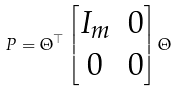Convert formula to latex. <formula><loc_0><loc_0><loc_500><loc_500>P = \Theta ^ { \top } \begin{bmatrix} I _ { m } & 0 \\ 0 & 0 \end{bmatrix} \Theta</formula> 